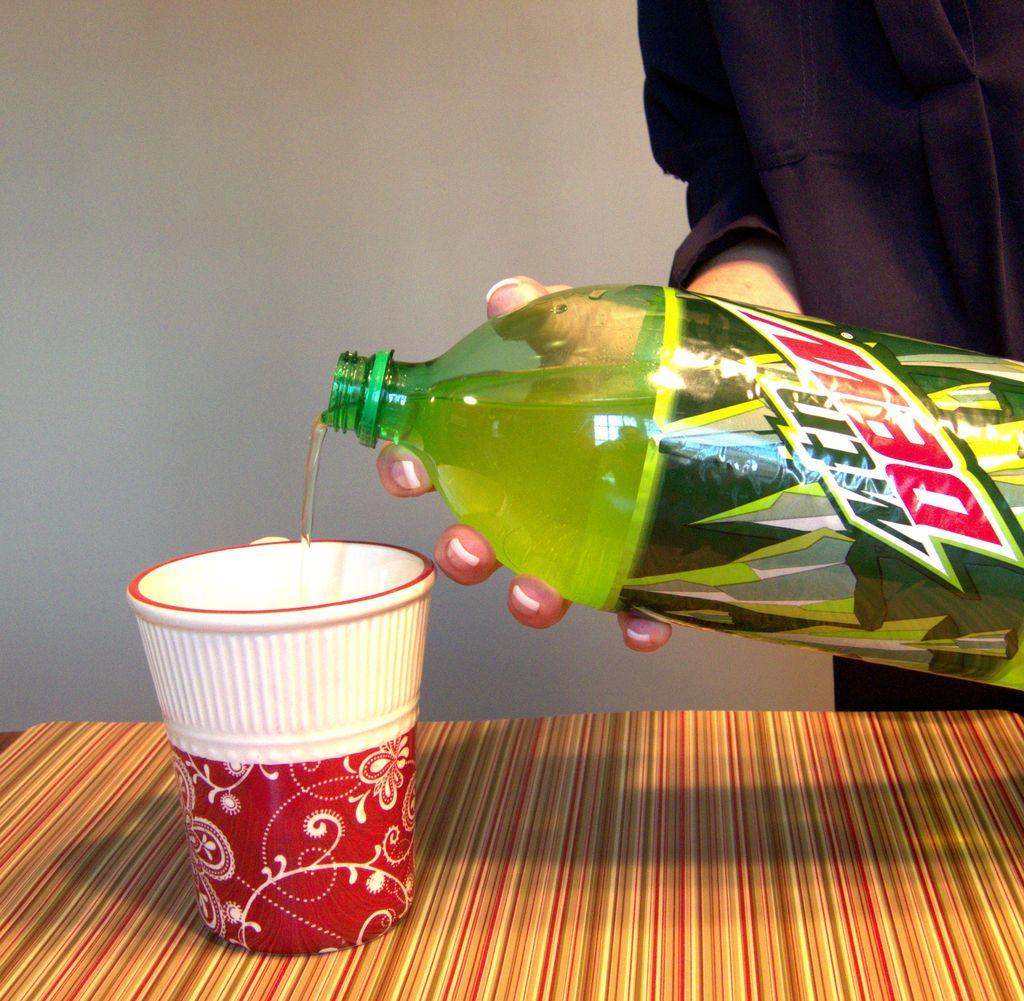What object is on the table in the image? There is a glass on a table in the image. What is happening with the glass in the image? A person is pouring a drink into the glass. What can be seen in the background of the image? There is a white-colored wall in the background of the image. Where is the nest located in the image? There is no nest present in the image. What type of screw is being used to hold the glass together in the image? The glass in the image is not held together by any screws; it is a single, solid object. 